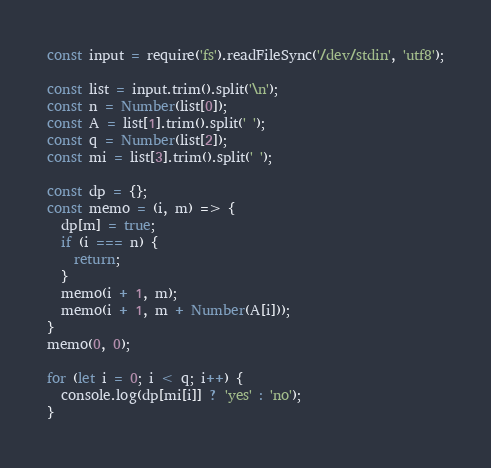Convert code to text. <code><loc_0><loc_0><loc_500><loc_500><_JavaScript_>const input = require('fs').readFileSync('/dev/stdin', 'utf8');

const list = input.trim().split('\n');
const n = Number(list[0]);
const A = list[1].trim().split(' ');
const q = Number(list[2]);
const mi = list[3].trim().split(' ');

const dp = {};
const memo = (i, m) => {
  dp[m] = true;
  if (i === n) {
    return;
  }
  memo(i + 1, m);
  memo(i + 1, m + Number(A[i]));
}
memo(0, 0);

for (let i = 0; i < q; i++) {
  console.log(dp[mi[i]] ? 'yes' : 'no');
}
</code> 